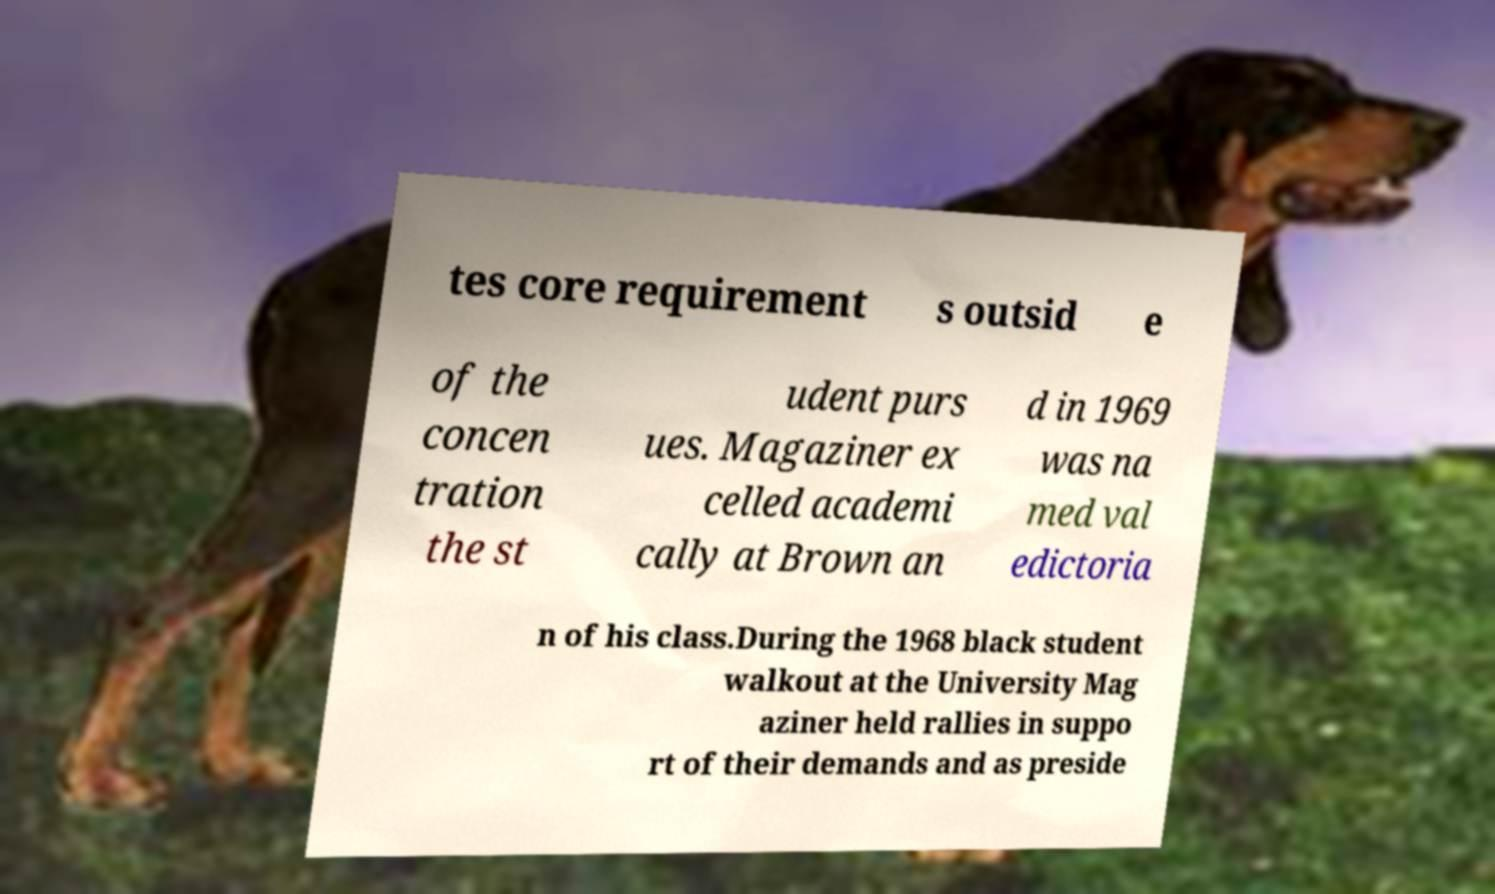Please identify and transcribe the text found in this image. tes core requirement s outsid e of the concen tration the st udent purs ues. Magaziner ex celled academi cally at Brown an d in 1969 was na med val edictoria n of his class.During the 1968 black student walkout at the University Mag aziner held rallies in suppo rt of their demands and as preside 